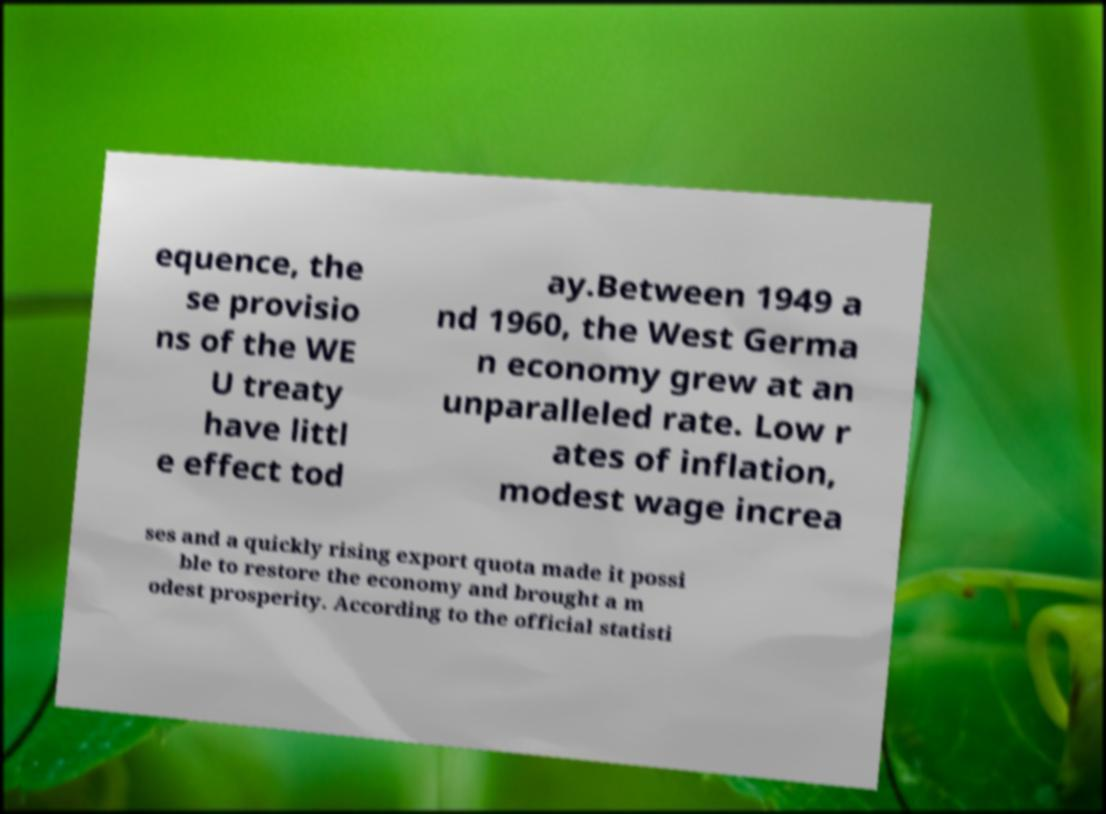There's text embedded in this image that I need extracted. Can you transcribe it verbatim? equence, the se provisio ns of the WE U treaty have littl e effect tod ay.Between 1949 a nd 1960, the West Germa n economy grew at an unparalleled rate. Low r ates of inflation, modest wage increa ses and a quickly rising export quota made it possi ble to restore the economy and brought a m odest prosperity. According to the official statisti 